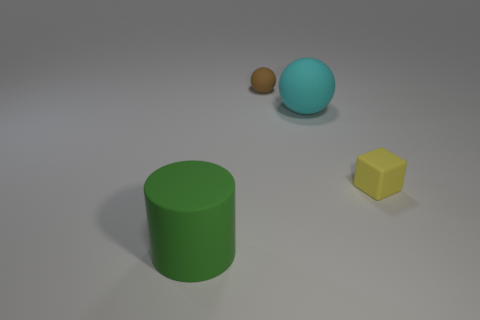Add 2 blue metal spheres. How many objects exist? 6 Subtract 1 spheres. How many spheres are left? 1 Subtract all cubes. How many objects are left? 3 Subtract all cyan cubes. Subtract all cyan balls. How many cubes are left? 1 Add 4 large rubber cylinders. How many large rubber cylinders are left? 5 Add 4 large blue shiny cylinders. How many large blue shiny cylinders exist? 4 Subtract 0 yellow balls. How many objects are left? 4 Subtract all cyan balls. How many brown cubes are left? 0 Subtract all red objects. Subtract all blocks. How many objects are left? 3 